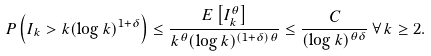Convert formula to latex. <formula><loc_0><loc_0><loc_500><loc_500>P \left ( I _ { k } > k ( \log k ) ^ { 1 + \delta } \right ) \leq \frac { E \left [ I _ { k } ^ { \theta } \right ] } { k ^ { \theta } ( \log k ) ^ { ( 1 + \delta ) \theta } } \leq \frac { C } { ( \log k ) ^ { \theta \delta } } \, \forall \, k \geq 2 .</formula> 